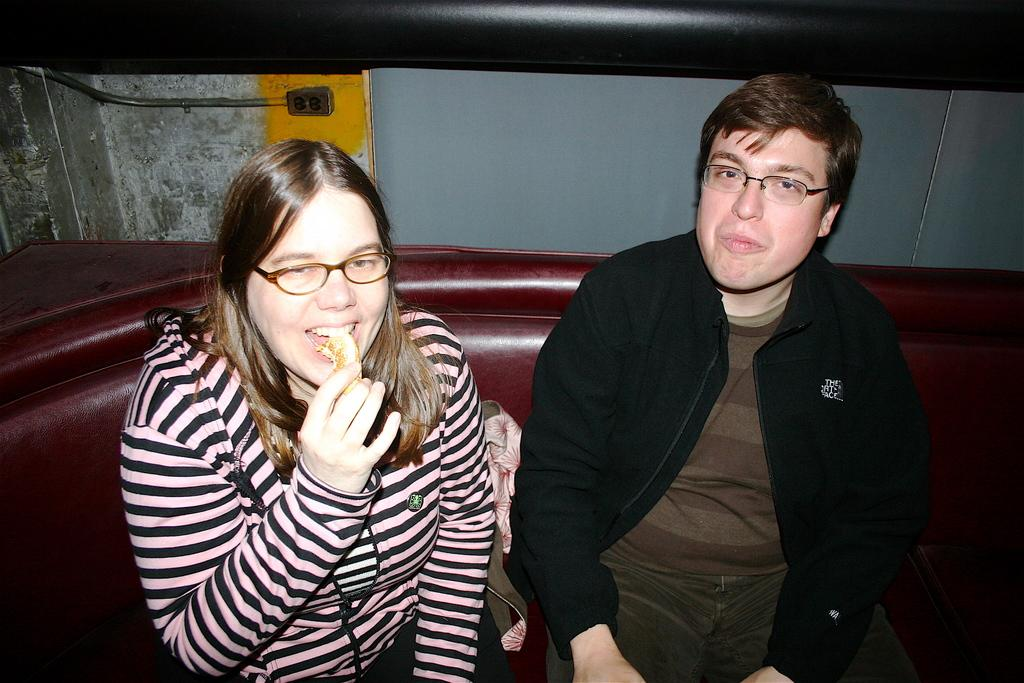Who can be seen in the image? There is a lady and a man in the image. What are they doing in the image? They are sitting on a sofa. What can be observed about their appearance? Both the lady and the man are wearing glasses. What is the lady holding in the image? The lady is holding a food item. What can be seen in the background of the image? There is a wall in the background of the image. What type of haircut does the lady have in the image? There is no information about the lady's haircut in the image. Can you describe the taste of the food item the lady is holding? There is no information about the taste of the food item in the image. 